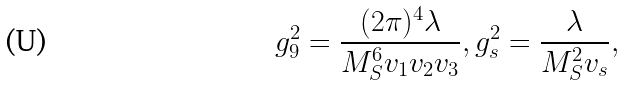<formula> <loc_0><loc_0><loc_500><loc_500>g _ { 9 } ^ { 2 } = \frac { ( 2 \pi ) ^ { 4 } \lambda } { M _ { S } ^ { 6 } v _ { 1 } v _ { 2 } v _ { 3 } } , g _ { s } ^ { 2 } = \frac { \lambda } { M _ { S } ^ { 2 } v _ { s } } ,</formula> 